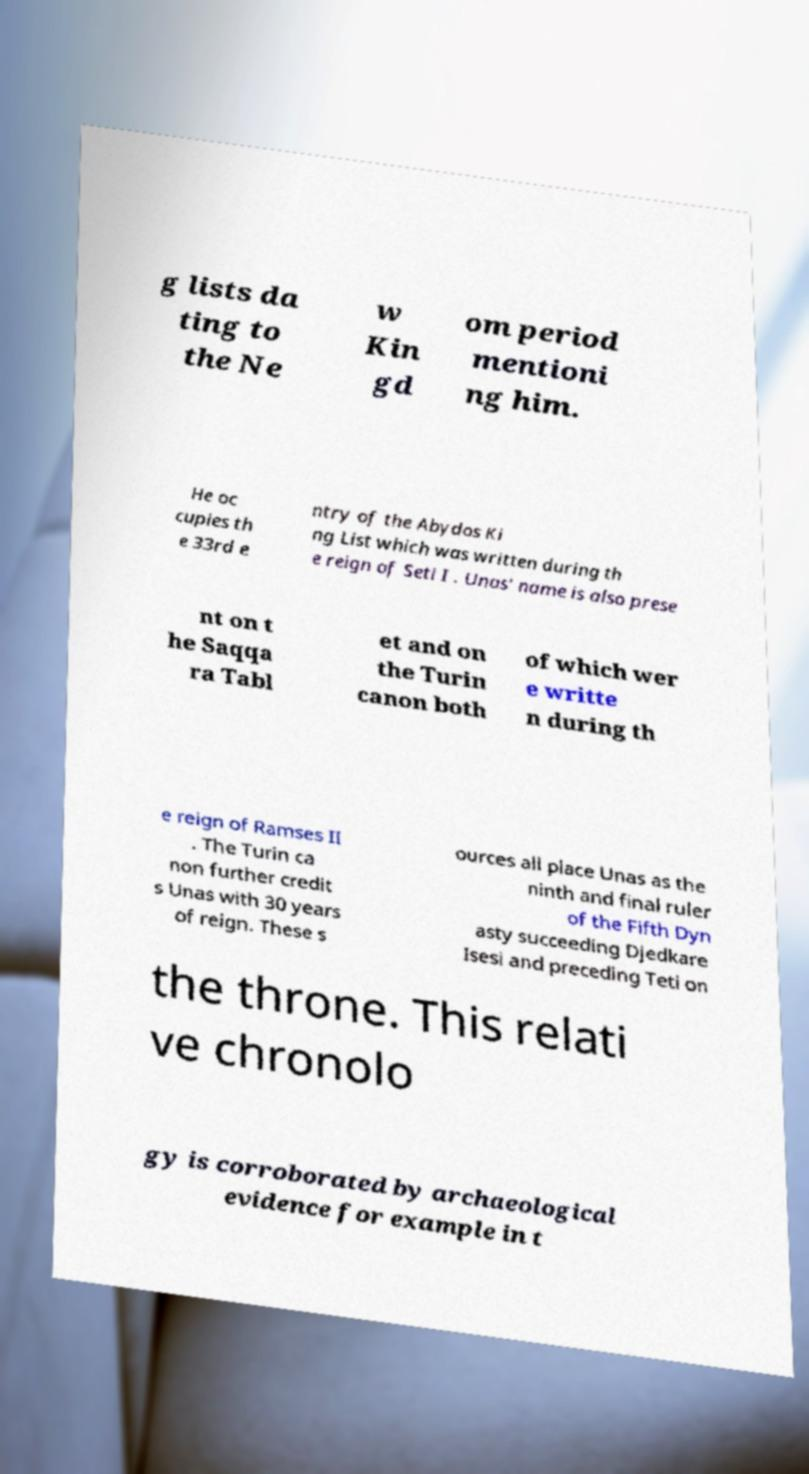Can you read and provide the text displayed in the image?This photo seems to have some interesting text. Can you extract and type it out for me? g lists da ting to the Ne w Kin gd om period mentioni ng him. He oc cupies th e 33rd e ntry of the Abydos Ki ng List which was written during th e reign of Seti I . Unas' name is also prese nt on t he Saqqa ra Tabl et and on the Turin canon both of which wer e writte n during th e reign of Ramses II . The Turin ca non further credit s Unas with 30 years of reign. These s ources all place Unas as the ninth and final ruler of the Fifth Dyn asty succeeding Djedkare Isesi and preceding Teti on the throne. This relati ve chronolo gy is corroborated by archaeological evidence for example in t 